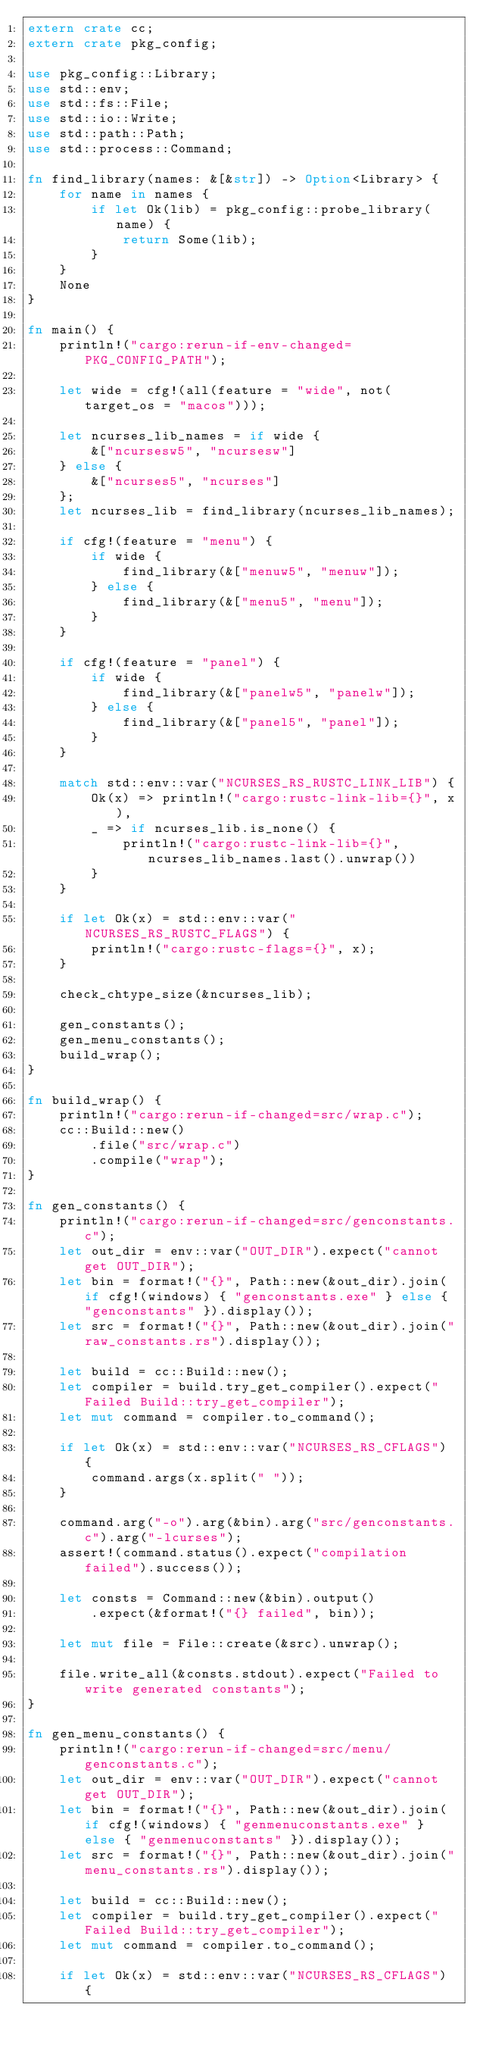<code> <loc_0><loc_0><loc_500><loc_500><_Rust_>extern crate cc;
extern crate pkg_config;

use pkg_config::Library;
use std::env;
use std::fs::File;
use std::io::Write;
use std::path::Path;
use std::process::Command;

fn find_library(names: &[&str]) -> Option<Library> {
    for name in names {
        if let Ok(lib) = pkg_config::probe_library(name) {
            return Some(lib);
        }
    }
    None
}

fn main() {
    println!("cargo:rerun-if-env-changed=PKG_CONFIG_PATH");

    let wide = cfg!(all(feature = "wide", not(target_os = "macos")));

    let ncurses_lib_names = if wide {
        &["ncursesw5", "ncursesw"]
    } else {
        &["ncurses5", "ncurses"]
    };
    let ncurses_lib = find_library(ncurses_lib_names);

    if cfg!(feature = "menu") {
        if wide {
            find_library(&["menuw5", "menuw"]);
        } else {
            find_library(&["menu5", "menu"]);
        }
    }

    if cfg!(feature = "panel") {
        if wide {
            find_library(&["panelw5", "panelw"]);
        } else {
            find_library(&["panel5", "panel"]);
        }
    }

    match std::env::var("NCURSES_RS_RUSTC_LINK_LIB") {
        Ok(x) => println!("cargo:rustc-link-lib={}", x),
        _ => if ncurses_lib.is_none() {
            println!("cargo:rustc-link-lib={}", ncurses_lib_names.last().unwrap())
        }
    }

    if let Ok(x) = std::env::var("NCURSES_RS_RUSTC_FLAGS") {
        println!("cargo:rustc-flags={}", x);
    }

    check_chtype_size(&ncurses_lib);

    gen_constants();
    gen_menu_constants();
    build_wrap();
}

fn build_wrap() {
    println!("cargo:rerun-if-changed=src/wrap.c");
    cc::Build::new()
        .file("src/wrap.c")
        .compile("wrap");
}

fn gen_constants() {
    println!("cargo:rerun-if-changed=src/genconstants.c");
    let out_dir = env::var("OUT_DIR").expect("cannot get OUT_DIR");
    let bin = format!("{}", Path::new(&out_dir).join(if cfg!(windows) { "genconstants.exe" } else { "genconstants" }).display());
    let src = format!("{}", Path::new(&out_dir).join("raw_constants.rs").display());

    let build = cc::Build::new();
    let compiler = build.try_get_compiler().expect("Failed Build::try_get_compiler");
    let mut command = compiler.to_command();

    if let Ok(x) = std::env::var("NCURSES_RS_CFLAGS") {
        command.args(x.split(" "));
    }    

    command.arg("-o").arg(&bin).arg("src/genconstants.c").arg("-lcurses");
    assert!(command.status().expect("compilation failed").success());

    let consts = Command::new(&bin).output()
        .expect(&format!("{} failed", bin));

    let mut file = File::create(&src).unwrap();
    
    file.write_all(&consts.stdout).expect("Failed to write generated constants");
}

fn gen_menu_constants() {
    println!("cargo:rerun-if-changed=src/menu/genconstants.c");
    let out_dir = env::var("OUT_DIR").expect("cannot get OUT_DIR");
    let bin = format!("{}", Path::new(&out_dir).join(if cfg!(windows) { "genmenuconstants.exe" } else { "genmenuconstants" }).display());
    let src = format!("{}", Path::new(&out_dir).join("menu_constants.rs").display());

    let build = cc::Build::new();
    let compiler = build.try_get_compiler().expect("Failed Build::try_get_compiler");
    let mut command = compiler.to_command();

    if let Ok(x) = std::env::var("NCURSES_RS_CFLAGS") {</code> 